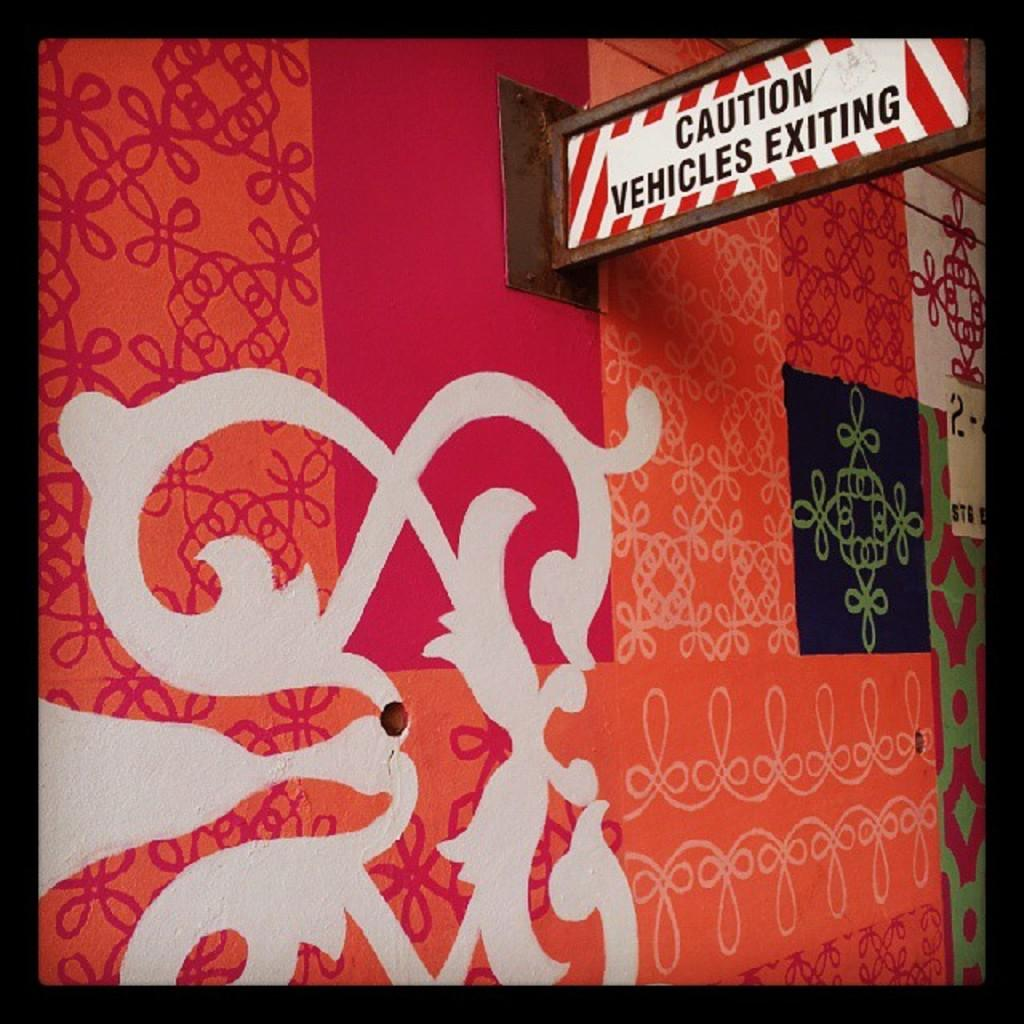<image>
Give a short and clear explanation of the subsequent image. A sign hanging off a building warns that vehicles are exiting. 